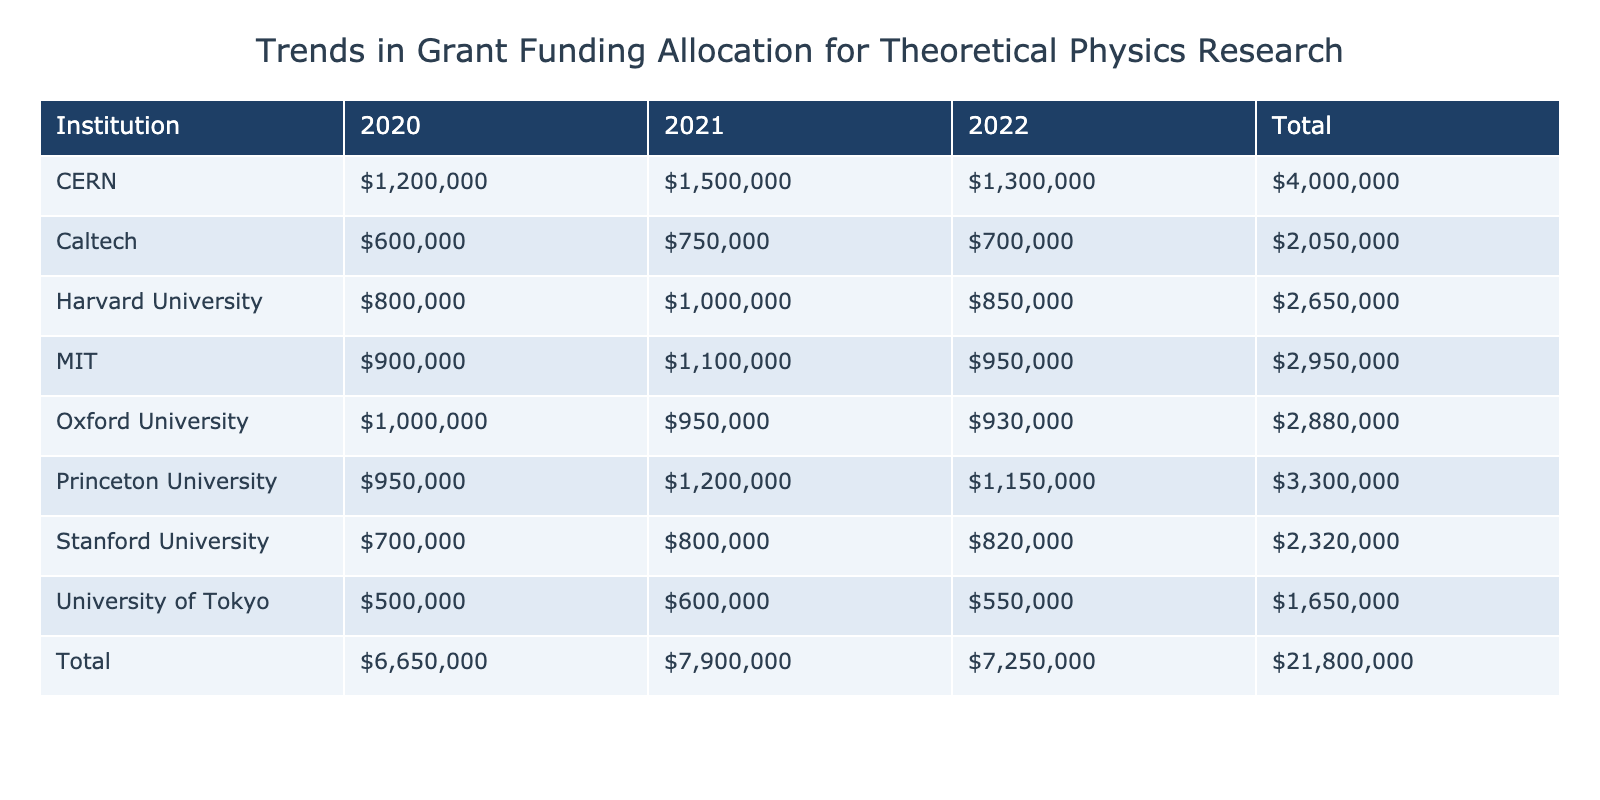What was the total grant amount for CERN in 2021? According to the table, the grant amount for CERN in 2021 is listed as $1,500,000.
Answer: $1,500,000 What is the average grant amount awarded to MIT over the three years? To find the average grant amount for MIT, we sum the amounts for 2020 ($900,000), 2021 ($1,100,000), and 2022 ($950,000), which totals $2,950,000. Then we divide by 3 (the number of years), yielding an average of $983,333.33.
Answer: $983,333.33 Did Oxford University receive more funding in 2020 than Stanford University? Yes, Oxford University received $1,000,000 in 2020, while Stanford University received $700,000. Since $1,000,000 is greater than $700,000, this statement is true.
Answer: Yes What was the total amount of grants awarded to Princeton University from 2020 to 2022? The total grant amount for Princeton University is calculated as follows: 2020 ($950,000) + 2021 ($1,200,000) + 2022 ($1,150,000) = $3,300,000.
Answer: $3,300,000 In which year did Caltech receive the least funding? To determine the year with the least funding for Caltech, we look at the grant amounts: 2020 ($600,000), 2021 ($750,000), and 2022 ($700,000). The smallest amount is $600,000, which corresponds to the year 2020.
Answer: 2020 What is the difference in grant amounts between Harvard University in 2021 and University of Tokyo in 2021? Harvard University received $1,000,000 in 2021 and the University of Tokyo received $600,000. The difference is $1,000,000 - $600,000 = $400,000.
Answer: $400,000 Which institution received the highest total grant amount across all three years? To find this, we must sum the grant amounts for each institution. After calculating, CERN totals $4,000,000, MIT totals $2,950,000, Harvard University totals $2,650,000, Princeton University totals $3,300,000, Stanford University totals $2,320,000, Caltech totals $2,050,000, Oxford University totals $2,930,000, and University of Tokyo totals $1,650,000. The highest is CERN with $4,000,000.
Answer: CERN Did University of Tokyo's grant amounts increase every year? No, the grant amounts for the University of Tokyo were $500,000 in 2020, $600,000 in 2021, and then decreased to $550,000 in 2022. Since there is a decrease from 2021 to 2022, this statement is false.
Answer: No What would be the overall grant sum if all institutions combined their funding in 2022? Adding all the amounts from the table for 2022: CERN ($1,300,000) + MIT ($950,000) + Harvard University ($850,000) + Princeton University ($1,150,000) + Stanford University ($820,000) + Caltech ($700,000) + Oxford University ($930,000) + University of Tokyo ($550,000) equals $6,400,000.
Answer: $6,400,000 